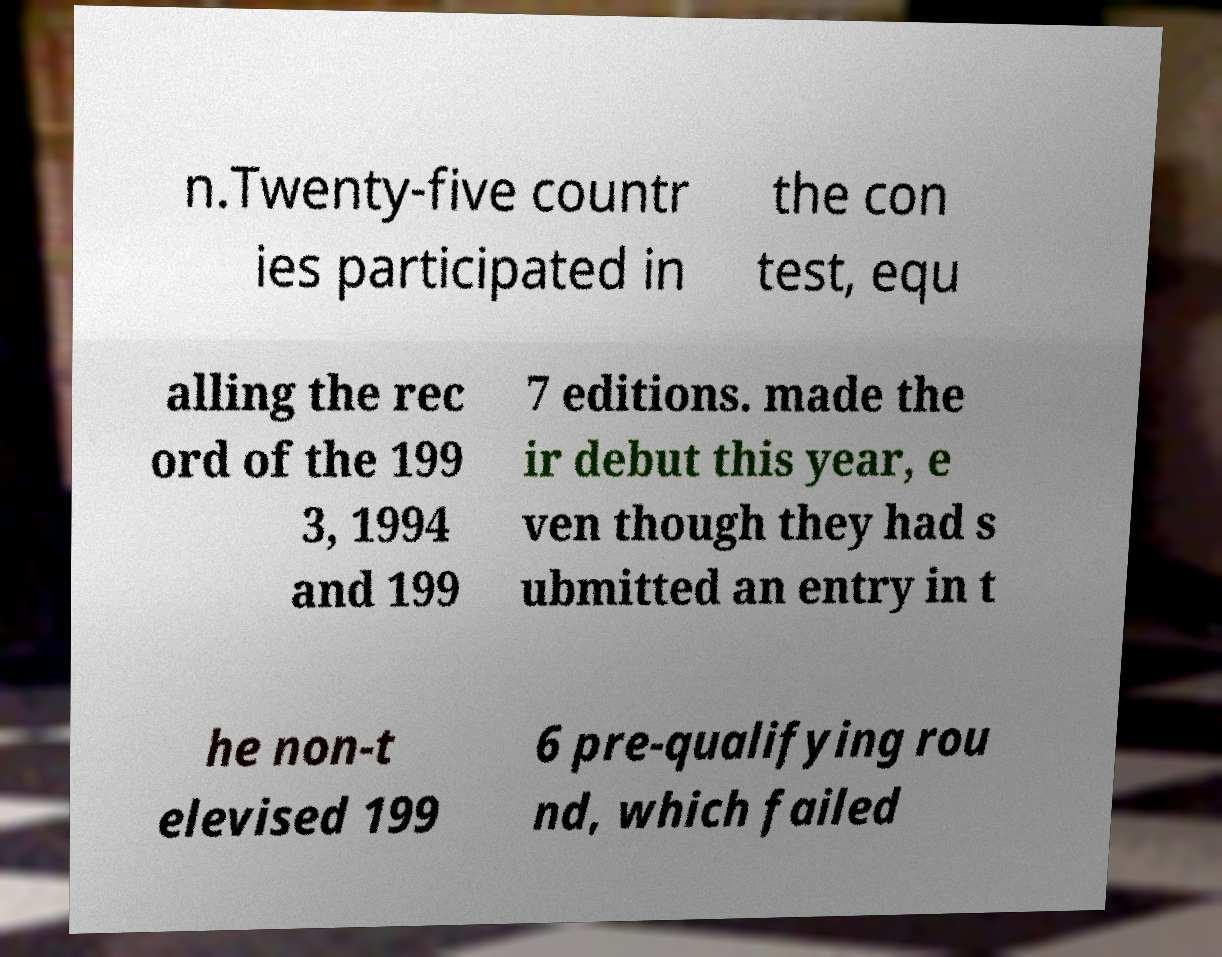Can you accurately transcribe the text from the provided image for me? n.Twenty-five countr ies participated in the con test, equ alling the rec ord of the 199 3, 1994 and 199 7 editions. made the ir debut this year, e ven though they had s ubmitted an entry in t he non-t elevised 199 6 pre-qualifying rou nd, which failed 